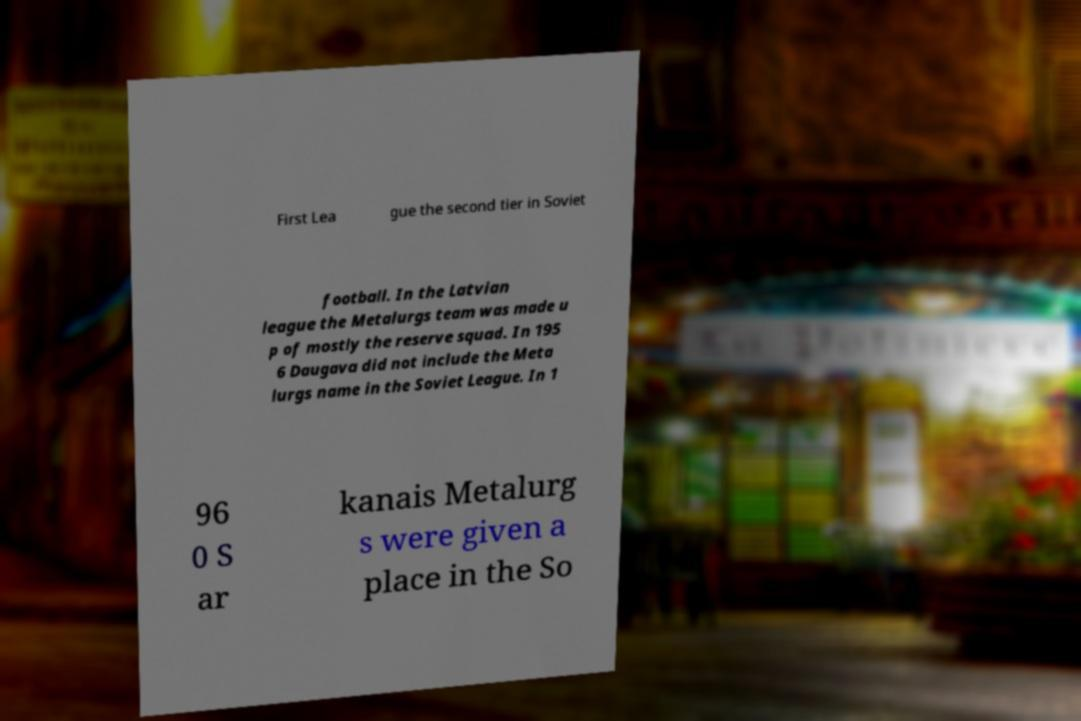I need the written content from this picture converted into text. Can you do that? First Lea gue the second tier in Soviet football. In the Latvian league the Metalurgs team was made u p of mostly the reserve squad. In 195 6 Daugava did not include the Meta lurgs name in the Soviet League. In 1 96 0 S ar kanais Metalurg s were given a place in the So 